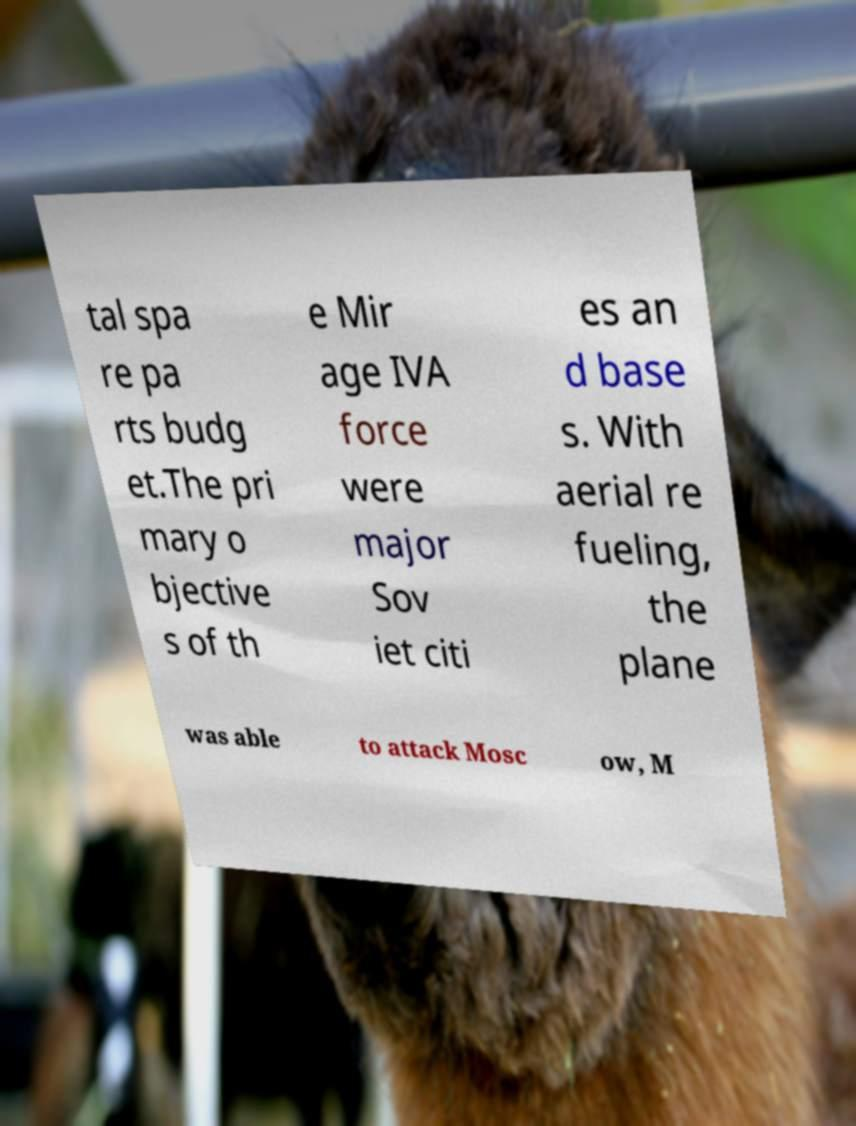Please identify and transcribe the text found in this image. tal spa re pa rts budg et.The pri mary o bjective s of th e Mir age IVA force were major Sov iet citi es an d base s. With aerial re fueling, the plane was able to attack Mosc ow, M 